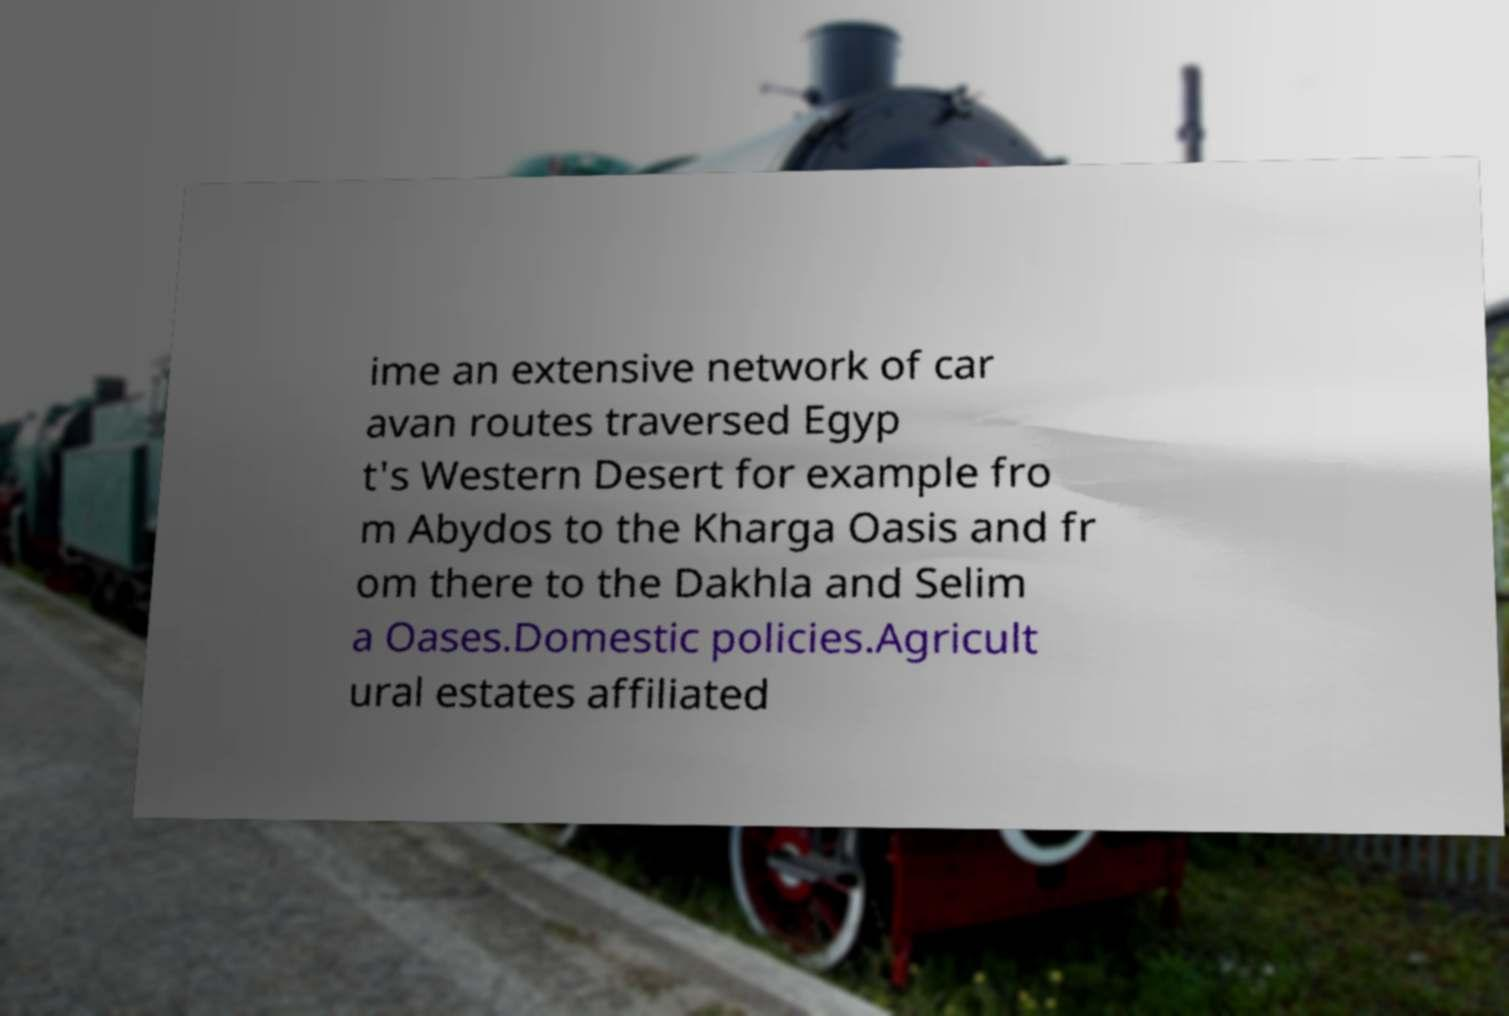For documentation purposes, I need the text within this image transcribed. Could you provide that? ime an extensive network of car avan routes traversed Egyp t's Western Desert for example fro m Abydos to the Kharga Oasis and fr om there to the Dakhla and Selim a Oases.Domestic policies.Agricult ural estates affiliated 